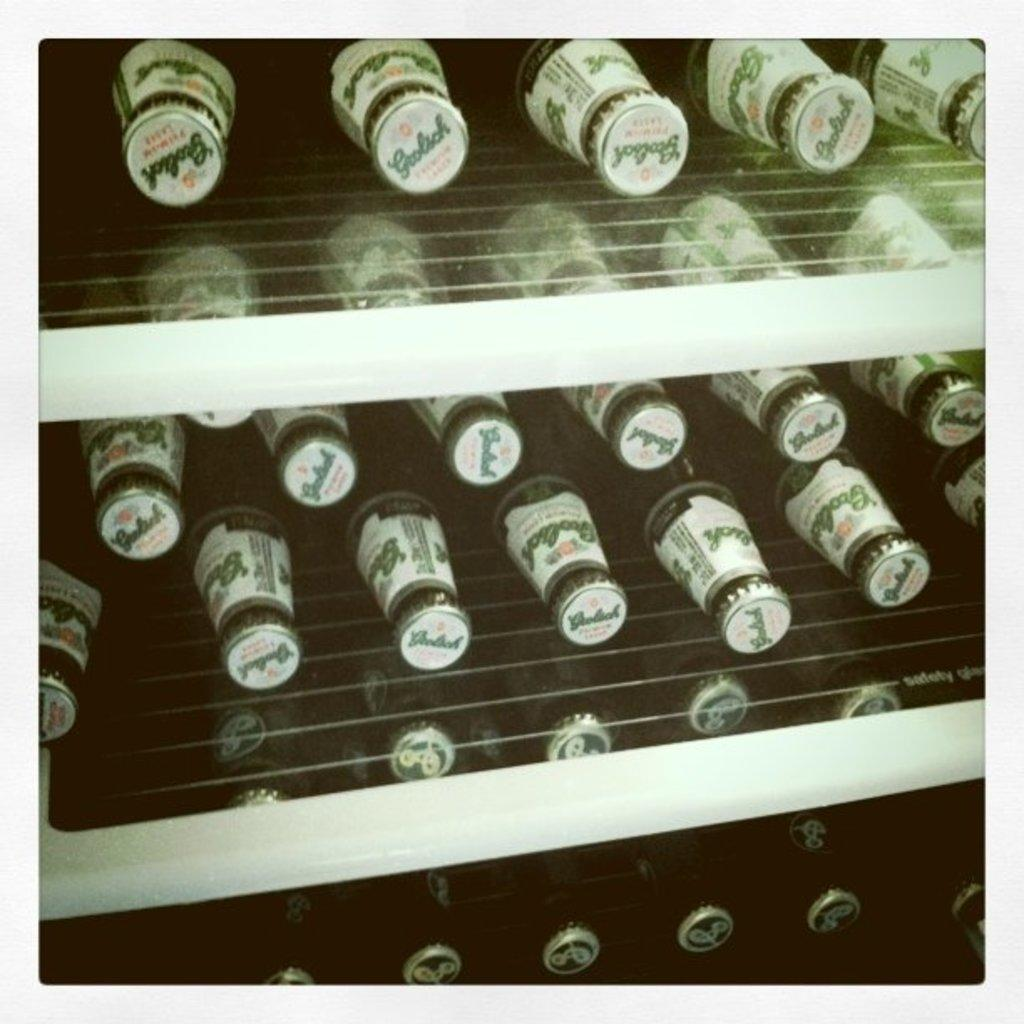What objects can be seen in the image? There are bottles in the image. Where are the bottles located? The bottles are on a shelf. How many snakes are crawling on the side of the bottles in the image? There are no snakes present in the image. 